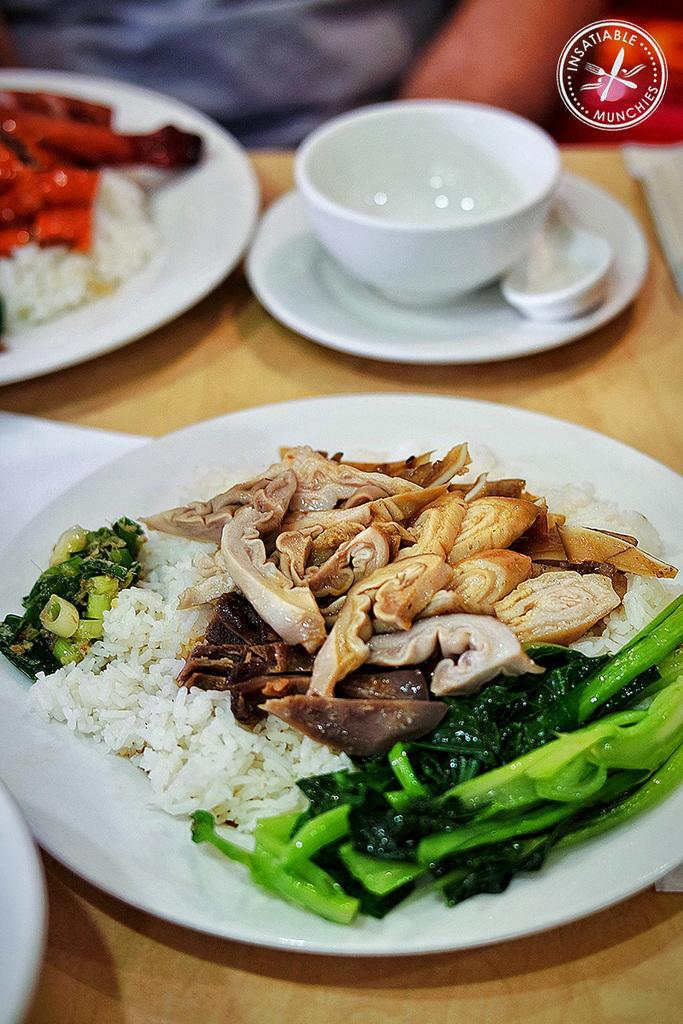What type of furniture is visible in the image? There is a table in the image. What is on top of the table? There are food items on a plate, and there is a bowl on the plate. What is inside the bowl? A spoon is present in the bowl. How does the nerve affect the food on the plate? There is no mention of a nerve in the image, and therefore it cannot affect the food on the plate. 